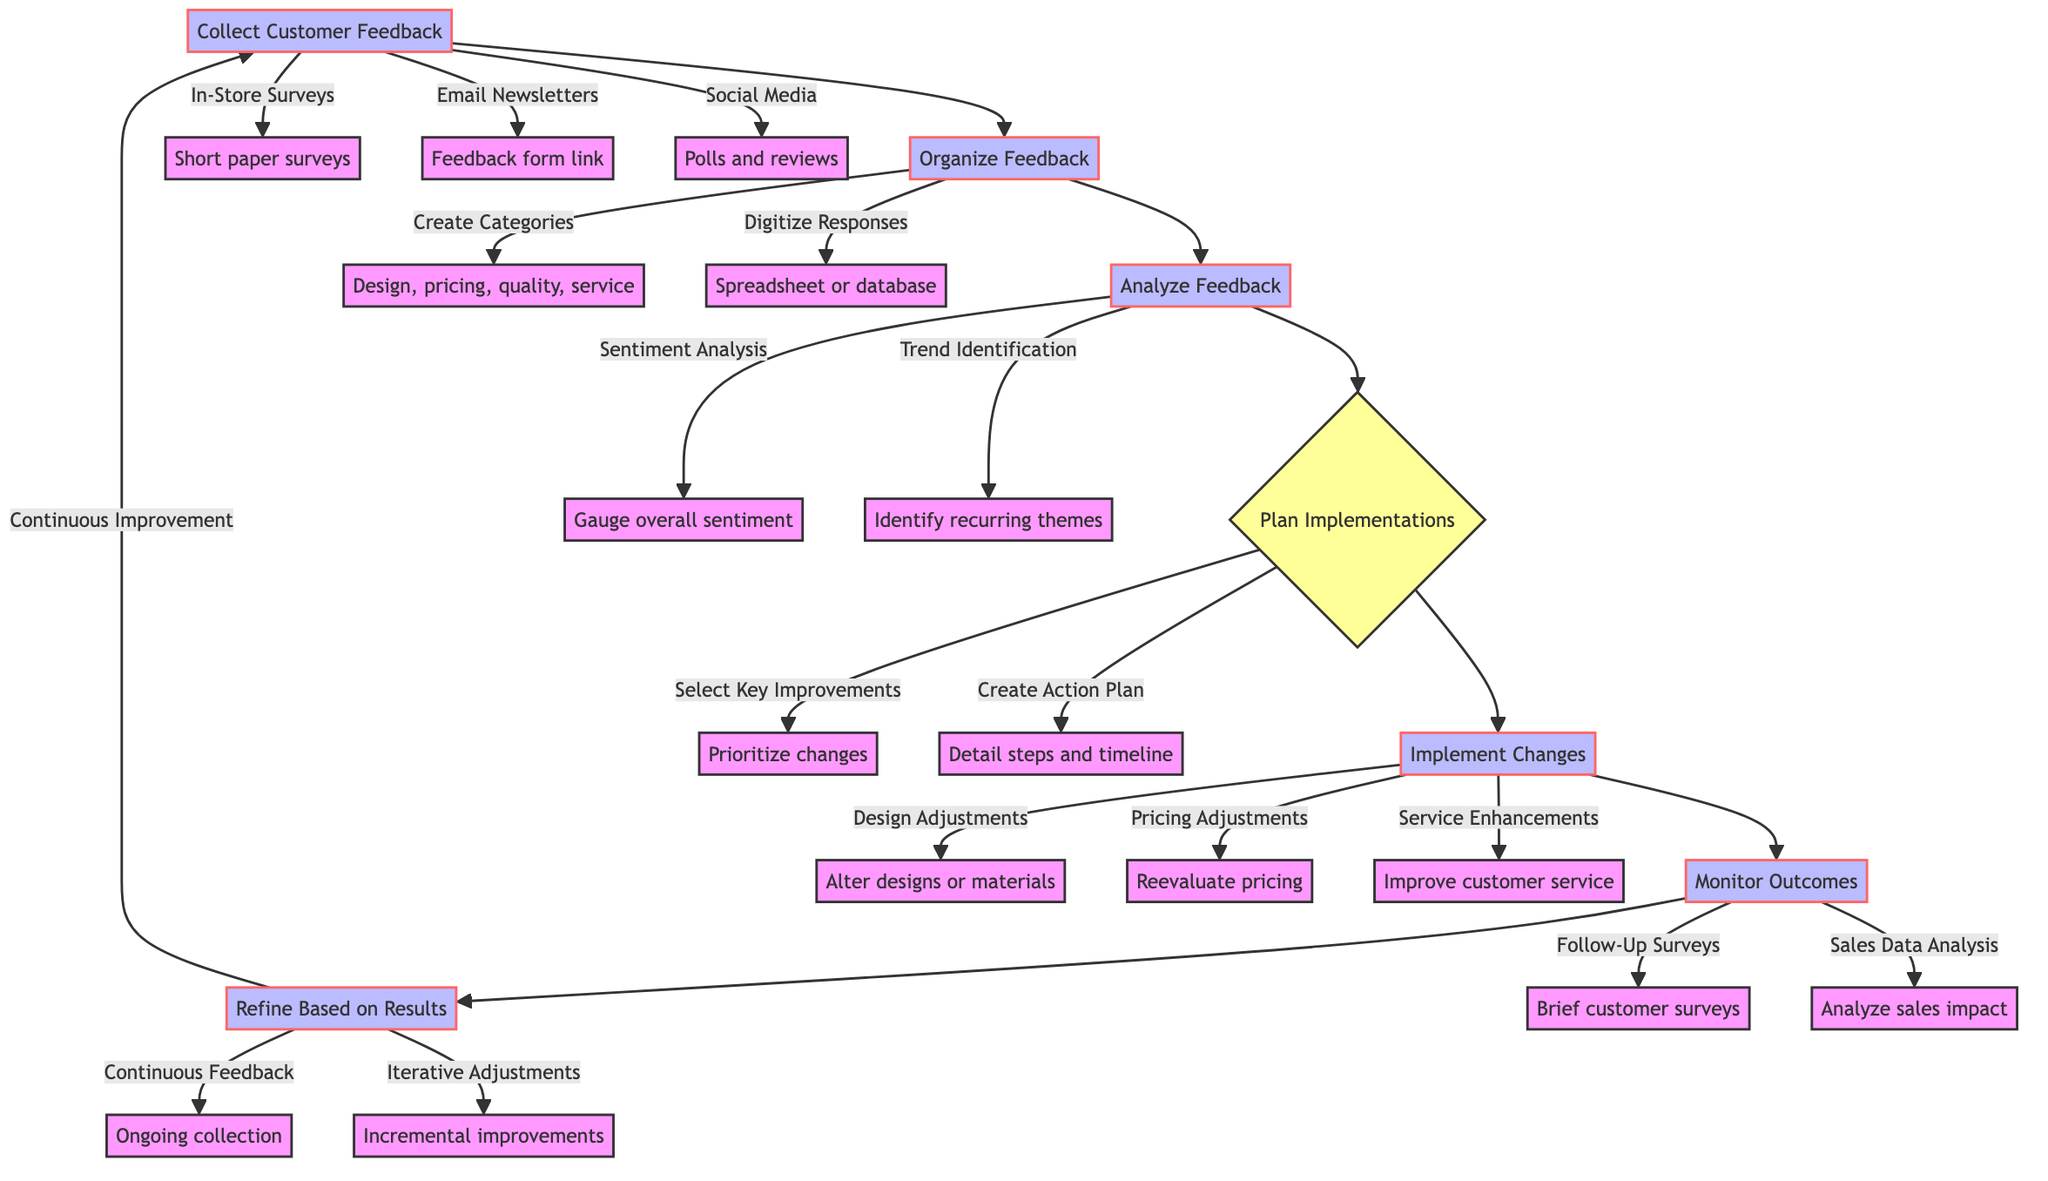What is the first step in the flow chart? The flow chart begins with "Collect Customer Feedback," indicating that this is the initial action in the process.
Answer: Collect Customer Feedback How many main processes are in the flow chart? By counting the main nodes (from collecting feedback to refining based on results), there are seven main processes illustrated in the diagram.
Answer: Seven Which channel is used for gathering feedback in-store? The diagram states "In-Store Surveys" as one of the channels used for collecting customer feedback physically in the store.
Answer: In-Store Surveys What action is taken after feedback has been analyzed? According to the flow chart, after analyzing feedback, the next step is to "Plan Implementations," which outlines actionable changes based on the collected feedback.
Answer: Plan Implementations What follows "Implement Changes" in the process? After the "Implement Changes" step, the next action is "Monitor Outcomes," which involves evaluating the effects of the changes.
Answer: Monitor Outcomes Which feedback organization task involves creating categories? The process of "Organize Feedback" includes a task named "Create Feedback Categories," where feedback themes are established.
Answer: Create Feedback Categories What type of analysis is performed to gauge overall sentiment? A method mentioned in the "Analyze Feedback" step is "Sentiment Analysis," which focuses on understanding whether feedback is positive or negative.
Answer: Sentiment Analysis What is the purpose of conducting follow-up surveys? The "Monitor Outcomes" step includes conducting "Follow-Up Surveys" to assess the effects of implemented changes on customer satisfaction directly.
Answer: Follow-Up Surveys What does "Iterative Adjustments" refer to in the context of the flow chart? In the "Refine Based on Results" section, "Iterative Adjustments" signifies making further improvements based on ongoing monitoring results and collected feedback.
Answer: Iterative Adjustments 